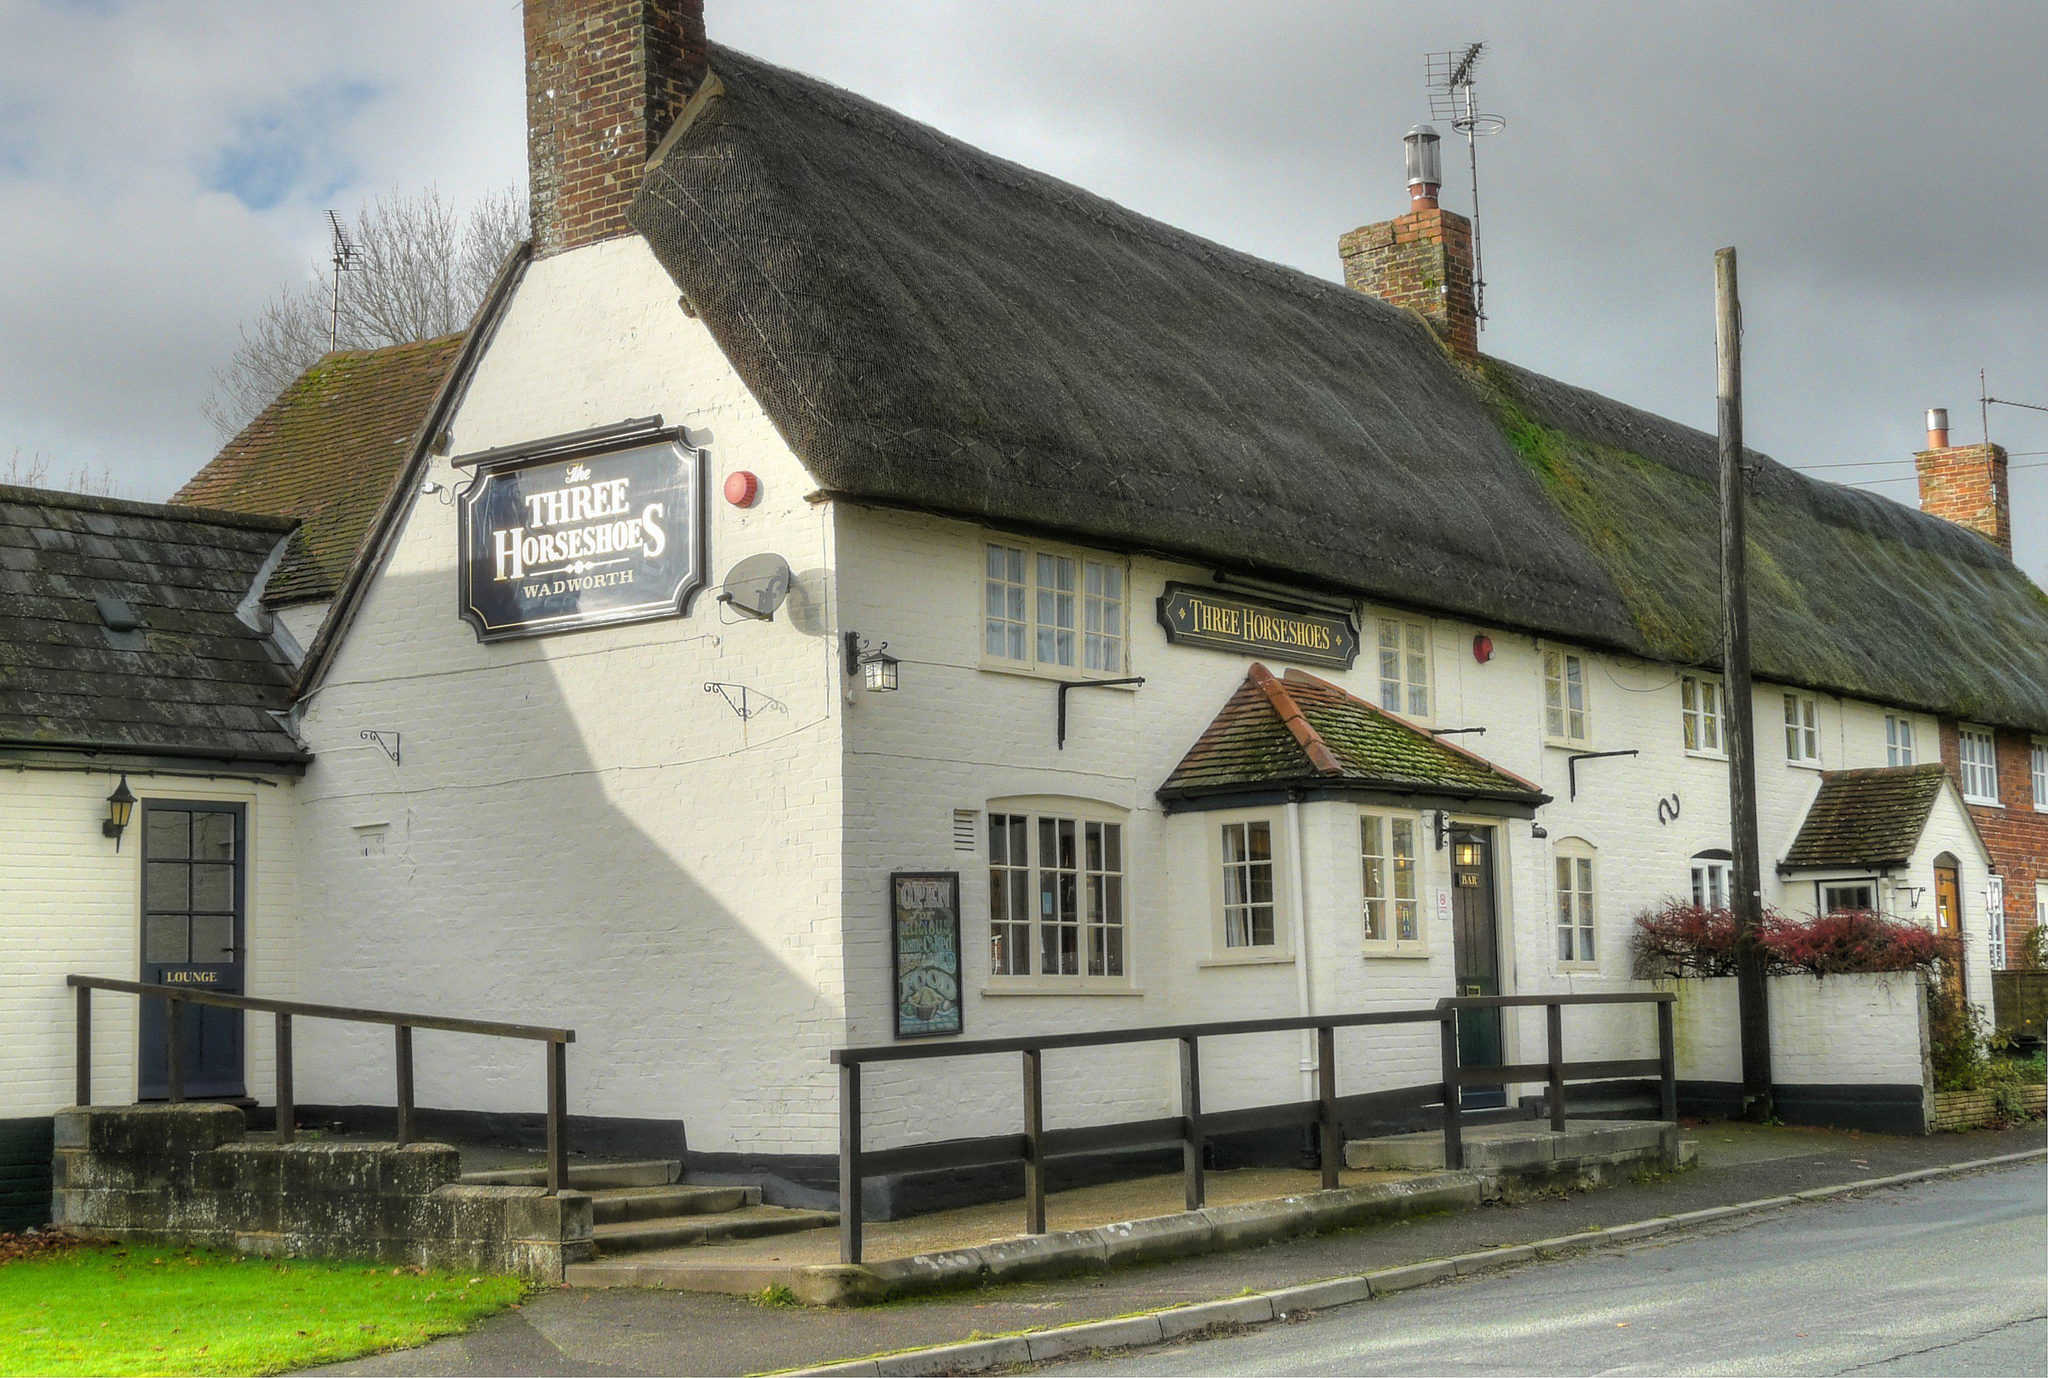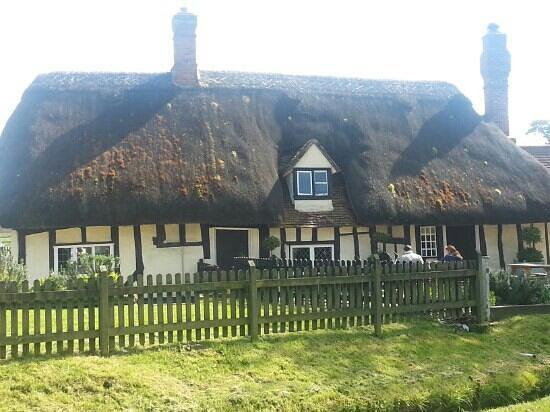The first image is the image on the left, the second image is the image on the right. Assess this claim about the two images: "In the right image at least two chimneys are visible.". Correct or not? Answer yes or no. Yes. The first image is the image on the left, the second image is the image on the right. Considering the images on both sides, is "There are at least four chimney on a total of two building with at least one being white." valid? Answer yes or no. Yes. 